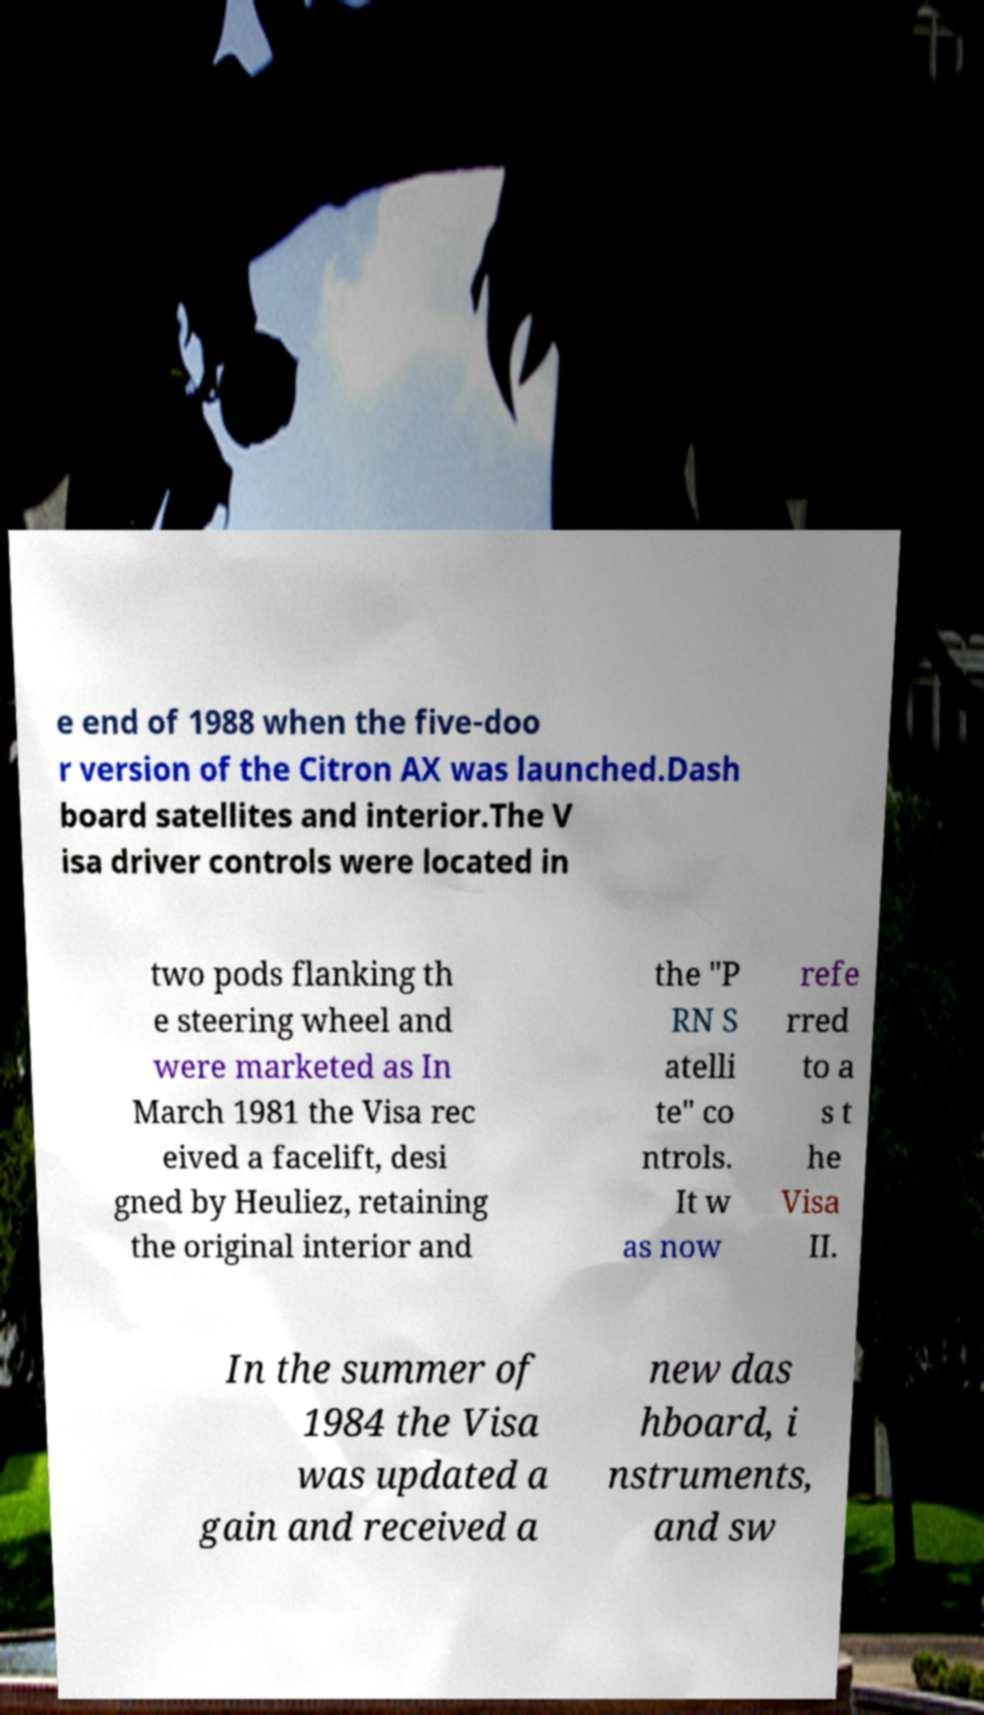What messages or text are displayed in this image? I need them in a readable, typed format. e end of 1988 when the five-doo r version of the Citron AX was launched.Dash board satellites and interior.The V isa driver controls were located in two pods flanking th e steering wheel and were marketed as In March 1981 the Visa rec eived a facelift, desi gned by Heuliez, retaining the original interior and the "P RN S atelli te" co ntrols. It w as now refe rred to a s t he Visa II. In the summer of 1984 the Visa was updated a gain and received a new das hboard, i nstruments, and sw 